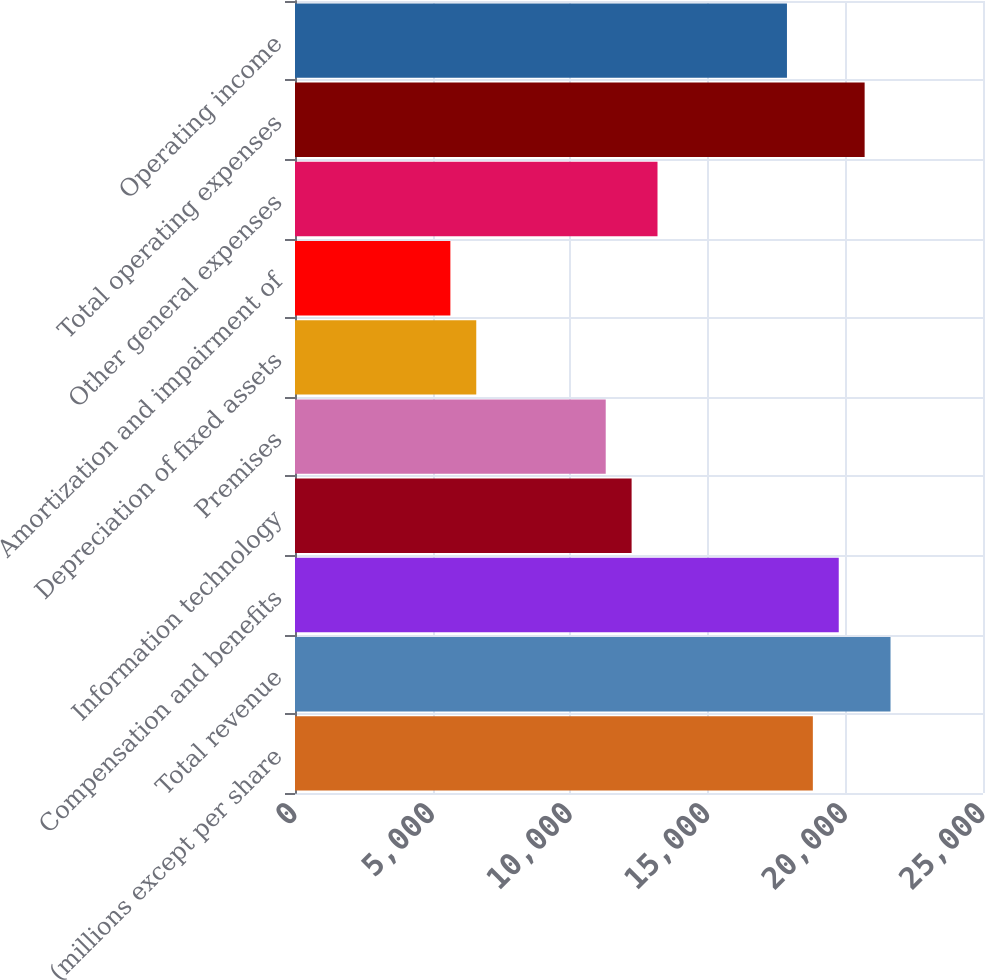Convert chart. <chart><loc_0><loc_0><loc_500><loc_500><bar_chart><fcel>(millions except per share<fcel>Total revenue<fcel>Compensation and benefits<fcel>Information technology<fcel>Premises<fcel>Depreciation of fixed assets<fcel>Amortization and impairment of<fcel>Other general expenses<fcel>Total operating expenses<fcel>Operating income<nl><fcel>18817.3<fcel>21639.8<fcel>19758.1<fcel>12231.5<fcel>11290.6<fcel>6586.47<fcel>5645.64<fcel>13172.3<fcel>20698.9<fcel>17876.4<nl></chart> 